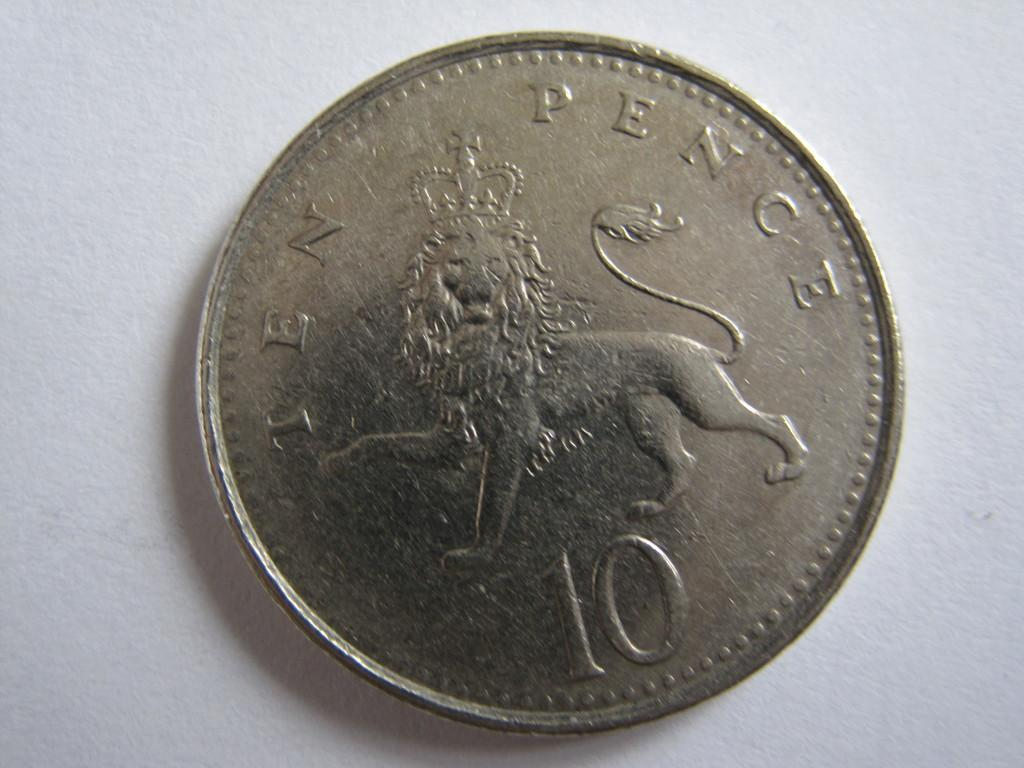<image>
Share a concise interpretation of the image provided. a silver coin with the words 'ten pence' on it 